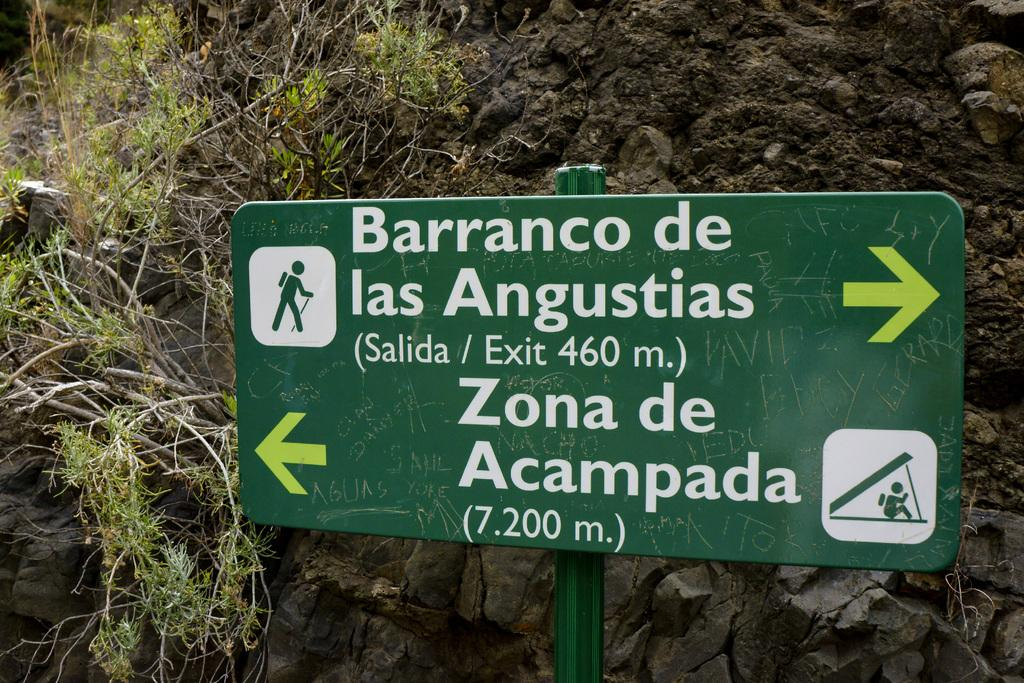What is the color of the board in the image? The board in the image is green. What is written on the board? There is writing on the board. What can be seen in the background of the image? There are plants in the background of the image. What type of nerve can be seen in the image? There is no nerve present in the image; it features a green color board with writing and plants in the background. 